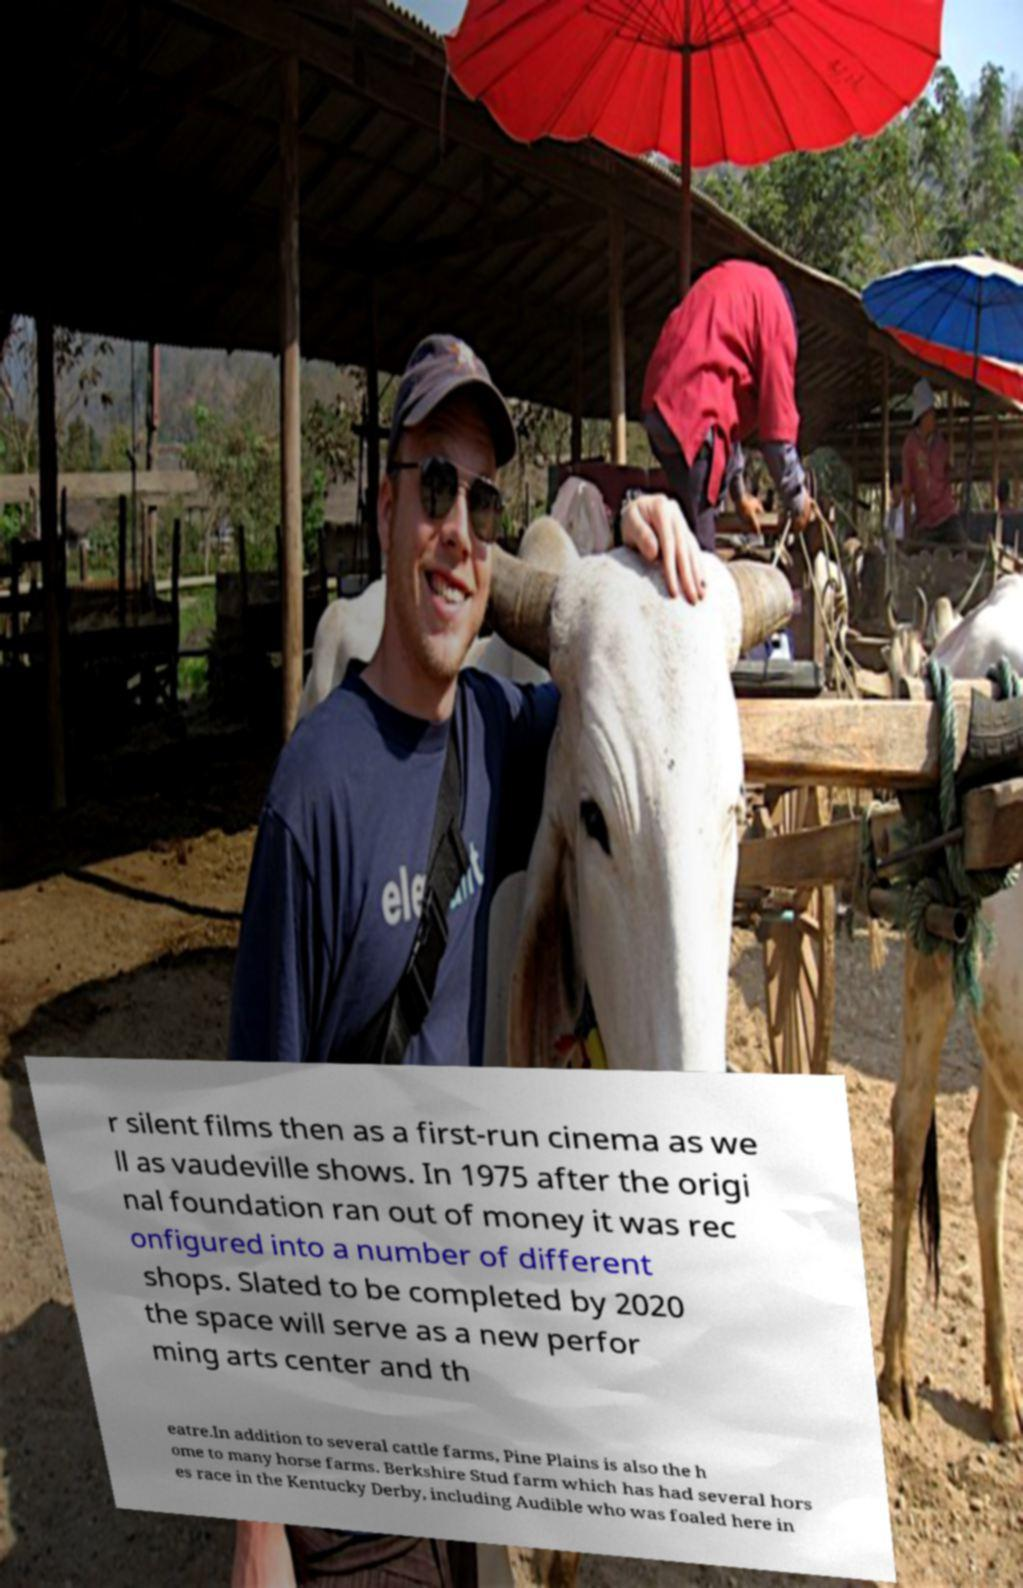Please identify and transcribe the text found in this image. r silent films then as a first-run cinema as we ll as vaudeville shows. In 1975 after the origi nal foundation ran out of money it was rec onfigured into a number of different shops. Slated to be completed by 2020 the space will serve as a new perfor ming arts center and th eatre.In addition to several cattle farms, Pine Plains is also the h ome to many horse farms. Berkshire Stud farm which has had several hors es race in the Kentucky Derby, including Audible who was foaled here in 